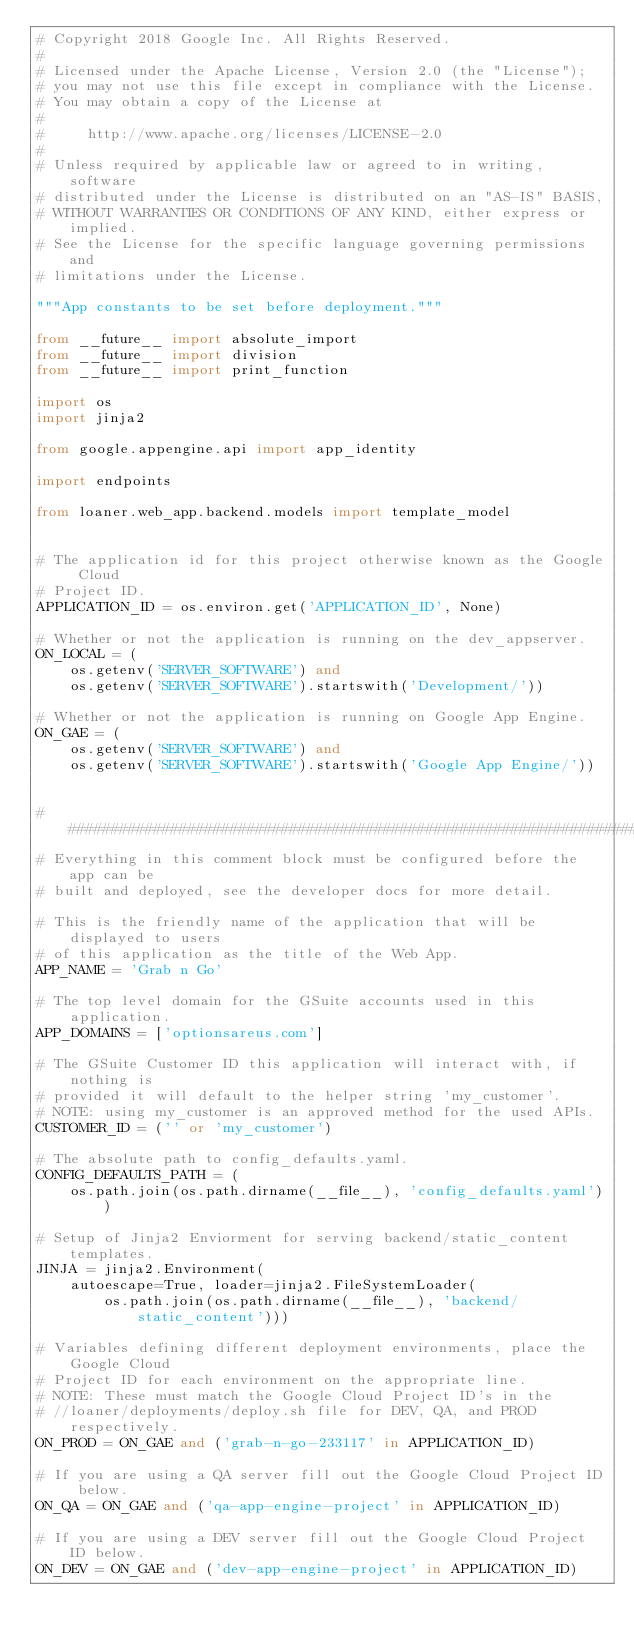Convert code to text. <code><loc_0><loc_0><loc_500><loc_500><_Python_># Copyright 2018 Google Inc. All Rights Reserved.
#
# Licensed under the Apache License, Version 2.0 (the "License");
# you may not use this file except in compliance with the License.
# You may obtain a copy of the License at
#
#     http://www.apache.org/licenses/LICENSE-2.0
#
# Unless required by applicable law or agreed to in writing, software
# distributed under the License is distributed on an "AS-IS" BASIS,
# WITHOUT WARRANTIES OR CONDITIONS OF ANY KIND, either express or implied.
# See the License for the specific language governing permissions and
# limitations under the License.

"""App constants to be set before deployment."""

from __future__ import absolute_import
from __future__ import division
from __future__ import print_function

import os
import jinja2

from google.appengine.api import app_identity

import endpoints

from loaner.web_app.backend.models import template_model


# The application id for this project otherwise known as the Google Cloud
# Project ID.
APPLICATION_ID = os.environ.get('APPLICATION_ID', None)

# Whether or not the application is running on the dev_appserver.
ON_LOCAL = (
    os.getenv('SERVER_SOFTWARE') and
    os.getenv('SERVER_SOFTWARE').startswith('Development/'))

# Whether or not the application is running on Google App Engine.
ON_GAE = (
    os.getenv('SERVER_SOFTWARE') and
    os.getenv('SERVER_SOFTWARE').startswith('Google App Engine/'))


################################################################################
# Everything in this comment block must be configured before the app can be
# built and deployed, see the developer docs for more detail.

# This is the friendly name of the application that will be displayed to users
# of this application as the title of the Web App.
APP_NAME = 'Grab n Go'

# The top level domain for the GSuite accounts used in this application.
APP_DOMAINS = ['optionsareus.com']

# The GSuite Customer ID this application will interact with, if nothing is
# provided it will default to the helper string 'my_customer'.
# NOTE: using my_customer is an approved method for the used APIs.
CUSTOMER_ID = ('' or 'my_customer')

# The absolute path to config_defaults.yaml.
CONFIG_DEFAULTS_PATH = (
    os.path.join(os.path.dirname(__file__), 'config_defaults.yaml'))

# Setup of Jinja2 Enviorment for serving backend/static_content templates.
JINJA = jinja2.Environment(
    autoescape=True, loader=jinja2.FileSystemLoader(
        os.path.join(os.path.dirname(__file__), 'backend/static_content')))

# Variables defining different deployment environments, place the Google Cloud
# Project ID for each environment on the appropriate line.
# NOTE: These must match the Google Cloud Project ID's in the
# //loaner/deployments/deploy.sh file for DEV, QA, and PROD respectively.
ON_PROD = ON_GAE and ('grab-n-go-233117' in APPLICATION_ID)

# If you are using a QA server fill out the Google Cloud Project ID below.
ON_QA = ON_GAE and ('qa-app-engine-project' in APPLICATION_ID)

# If you are using a DEV server fill out the Google Cloud Project ID below.
ON_DEV = ON_GAE and ('dev-app-engine-project' in APPLICATION_ID)
</code> 